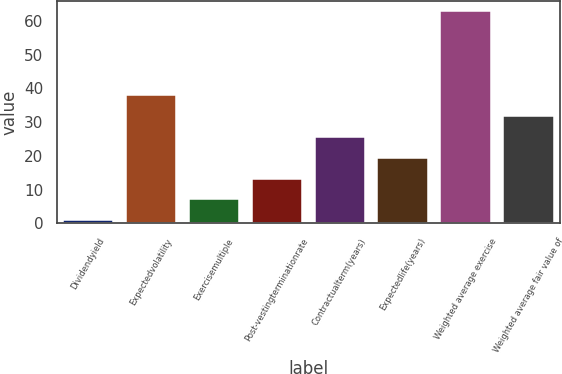Convert chart. <chart><loc_0><loc_0><loc_500><loc_500><bar_chart><fcel>Dividendyield<fcel>Expectedvolatility<fcel>Exercisemultiple<fcel>Post-vestingterminationrate<fcel>Contractualterm(years)<fcel>Expectedlife(years)<fcel>Weighted average exercise<fcel>Weighted average fair value of<nl><fcel>0.94<fcel>38.08<fcel>7.13<fcel>13.32<fcel>25.7<fcel>19.51<fcel>62.86<fcel>31.89<nl></chart> 